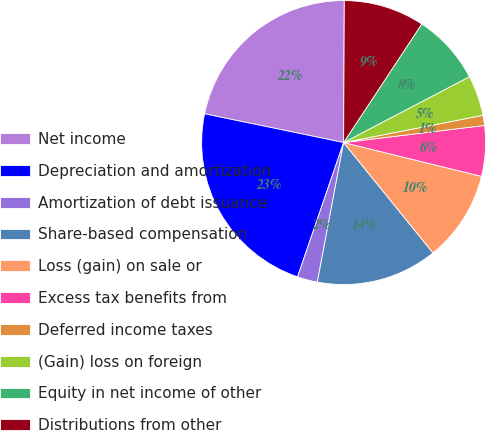Convert chart to OTSL. <chart><loc_0><loc_0><loc_500><loc_500><pie_chart><fcel>Net income<fcel>Depreciation and amortization<fcel>Amortization of debt issuance<fcel>Share-based compensation<fcel>Loss (gain) on sale or<fcel>Excess tax benefits from<fcel>Deferred income taxes<fcel>(Gain) loss on foreign<fcel>Equity in net income of other<fcel>Distributions from other<nl><fcel>21.83%<fcel>22.98%<fcel>2.3%<fcel>13.79%<fcel>10.34%<fcel>5.75%<fcel>1.15%<fcel>4.6%<fcel>8.05%<fcel>9.2%<nl></chart> 